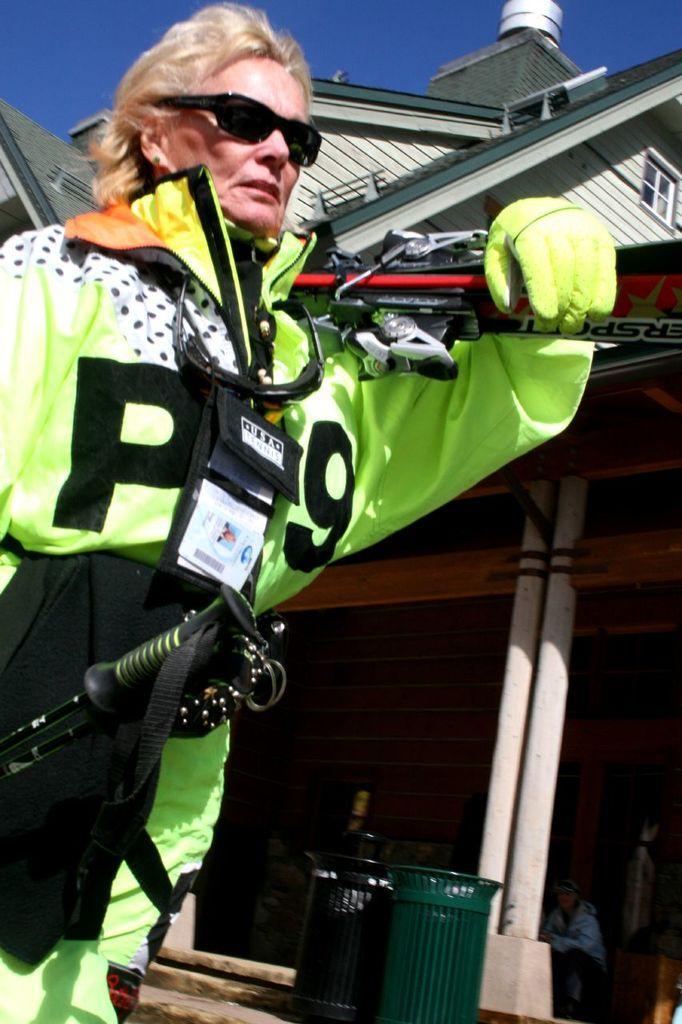Please provide a concise description of this image. In this image in the front there is a woman standing. In front of the woman there are objects which are green and black in colour. In the background there is a person sitting and there are pillars and there is a building. 